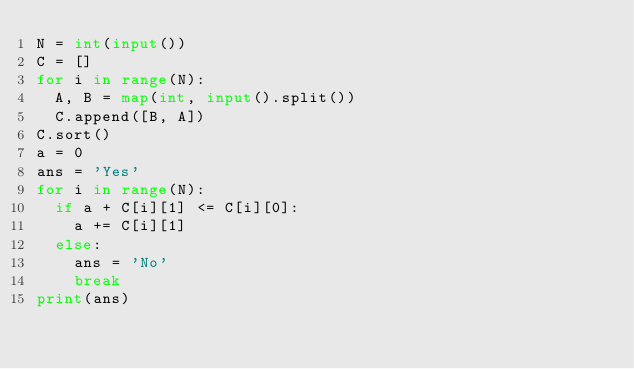Convert code to text. <code><loc_0><loc_0><loc_500><loc_500><_Python_>N = int(input())
C = []
for i in range(N):
  A, B = map(int, input().split())
  C.append([B, A])
C.sort()
a = 0
ans = 'Yes'
for i in range(N):
  if a + C[i][1] <= C[i][0]:
    a += C[i][1]
  else:
    ans = 'No'
    break
print(ans)
  </code> 